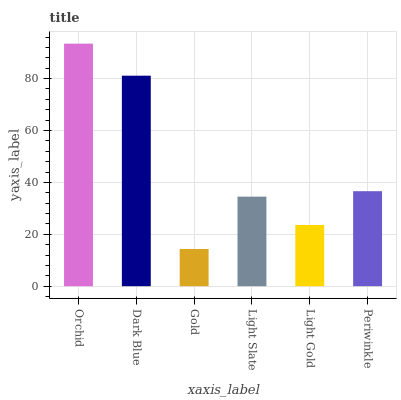Is Gold the minimum?
Answer yes or no. Yes. Is Orchid the maximum?
Answer yes or no. Yes. Is Dark Blue the minimum?
Answer yes or no. No. Is Dark Blue the maximum?
Answer yes or no. No. Is Orchid greater than Dark Blue?
Answer yes or no. Yes. Is Dark Blue less than Orchid?
Answer yes or no. Yes. Is Dark Blue greater than Orchid?
Answer yes or no. No. Is Orchid less than Dark Blue?
Answer yes or no. No. Is Periwinkle the high median?
Answer yes or no. Yes. Is Light Slate the low median?
Answer yes or no. Yes. Is Light Gold the high median?
Answer yes or no. No. Is Gold the low median?
Answer yes or no. No. 